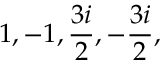<formula> <loc_0><loc_0><loc_500><loc_500>1 , - 1 , { \frac { 3 i } { 2 } } , - { \frac { 3 i } { 2 } } ,</formula> 